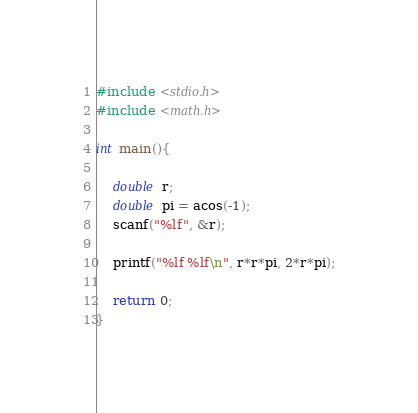Convert code to text. <code><loc_0><loc_0><loc_500><loc_500><_C_>#include <stdio.h>
#include <math.h>

int main(){
    
    double r;
    double pi = acos(-1);
    scanf("%lf", &r);

    printf("%lf %lf\n", r*r*pi, 2*r*pi);

    return 0;
}
</code> 